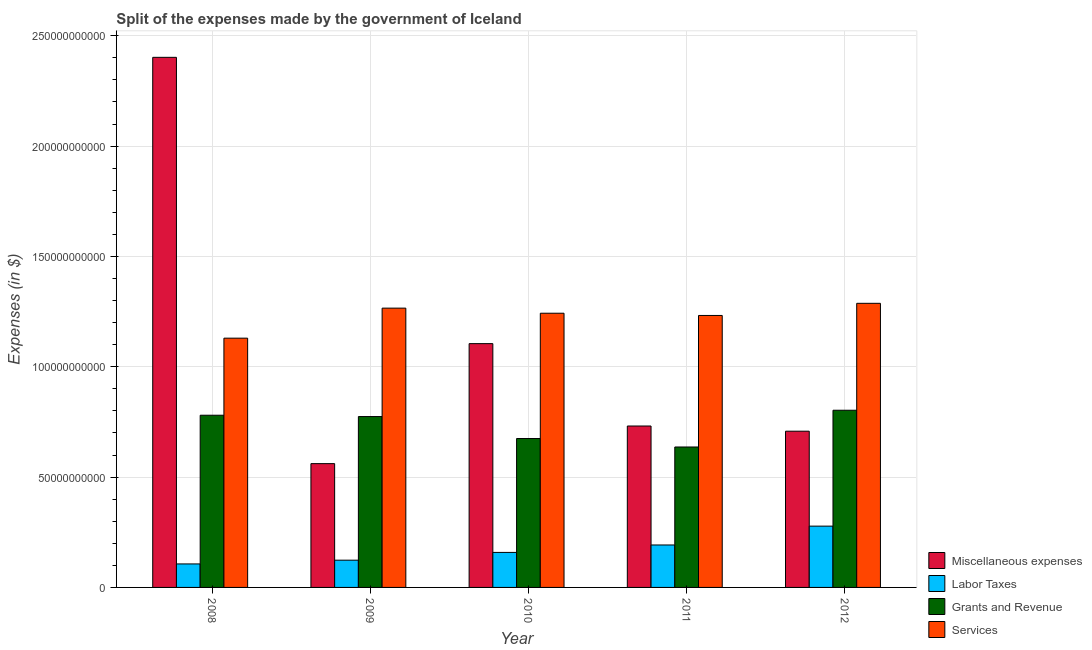How many groups of bars are there?
Give a very brief answer. 5. Are the number of bars on each tick of the X-axis equal?
Make the answer very short. Yes. How many bars are there on the 3rd tick from the left?
Provide a succinct answer. 4. What is the amount spent on services in 2012?
Make the answer very short. 1.29e+11. Across all years, what is the maximum amount spent on services?
Your response must be concise. 1.29e+11. Across all years, what is the minimum amount spent on miscellaneous expenses?
Provide a succinct answer. 5.61e+1. In which year was the amount spent on labor taxes minimum?
Your answer should be compact. 2008. What is the total amount spent on grants and revenue in the graph?
Keep it short and to the point. 3.67e+11. What is the difference between the amount spent on grants and revenue in 2008 and that in 2009?
Ensure brevity in your answer.  6.04e+08. What is the difference between the amount spent on miscellaneous expenses in 2009 and the amount spent on services in 2010?
Ensure brevity in your answer.  -5.44e+1. What is the average amount spent on services per year?
Offer a very short reply. 1.23e+11. In how many years, is the amount spent on grants and revenue greater than 70000000000 $?
Ensure brevity in your answer.  3. What is the ratio of the amount spent on miscellaneous expenses in 2008 to that in 2011?
Give a very brief answer. 3.28. Is the difference between the amount spent on services in 2008 and 2009 greater than the difference between the amount spent on grants and revenue in 2008 and 2009?
Ensure brevity in your answer.  No. What is the difference between the highest and the second highest amount spent on grants and revenue?
Provide a succinct answer. 2.26e+09. What is the difference between the highest and the lowest amount spent on labor taxes?
Your answer should be very brief. 1.71e+1. Is the sum of the amount spent on miscellaneous expenses in 2010 and 2012 greater than the maximum amount spent on grants and revenue across all years?
Offer a very short reply. No. Is it the case that in every year, the sum of the amount spent on services and amount spent on labor taxes is greater than the sum of amount spent on miscellaneous expenses and amount spent on grants and revenue?
Give a very brief answer. No. What does the 3rd bar from the left in 2012 represents?
Keep it short and to the point. Grants and Revenue. What does the 1st bar from the right in 2010 represents?
Offer a terse response. Services. Is it the case that in every year, the sum of the amount spent on miscellaneous expenses and amount spent on labor taxes is greater than the amount spent on grants and revenue?
Your response must be concise. No. How many bars are there?
Your response must be concise. 20. Are all the bars in the graph horizontal?
Provide a short and direct response. No. How many years are there in the graph?
Keep it short and to the point. 5. Are the values on the major ticks of Y-axis written in scientific E-notation?
Keep it short and to the point. No. Where does the legend appear in the graph?
Keep it short and to the point. Bottom right. What is the title of the graph?
Give a very brief answer. Split of the expenses made by the government of Iceland. Does "Gender equality" appear as one of the legend labels in the graph?
Keep it short and to the point. No. What is the label or title of the Y-axis?
Your response must be concise. Expenses (in $). What is the Expenses (in $) in Miscellaneous expenses in 2008?
Your answer should be very brief. 2.40e+11. What is the Expenses (in $) of Labor Taxes in 2008?
Offer a very short reply. 1.06e+1. What is the Expenses (in $) in Grants and Revenue in 2008?
Your answer should be compact. 7.80e+1. What is the Expenses (in $) in Services in 2008?
Make the answer very short. 1.13e+11. What is the Expenses (in $) of Miscellaneous expenses in 2009?
Provide a short and direct response. 5.61e+1. What is the Expenses (in $) of Labor Taxes in 2009?
Provide a succinct answer. 1.23e+1. What is the Expenses (in $) of Grants and Revenue in 2009?
Make the answer very short. 7.74e+1. What is the Expenses (in $) of Services in 2009?
Ensure brevity in your answer.  1.27e+11. What is the Expenses (in $) of Miscellaneous expenses in 2010?
Your answer should be compact. 1.10e+11. What is the Expenses (in $) in Labor Taxes in 2010?
Ensure brevity in your answer.  1.59e+1. What is the Expenses (in $) of Grants and Revenue in 2010?
Make the answer very short. 6.75e+1. What is the Expenses (in $) in Services in 2010?
Your answer should be very brief. 1.24e+11. What is the Expenses (in $) of Miscellaneous expenses in 2011?
Keep it short and to the point. 7.31e+1. What is the Expenses (in $) of Labor Taxes in 2011?
Provide a short and direct response. 1.92e+1. What is the Expenses (in $) in Grants and Revenue in 2011?
Make the answer very short. 6.36e+1. What is the Expenses (in $) of Services in 2011?
Your response must be concise. 1.23e+11. What is the Expenses (in $) of Miscellaneous expenses in 2012?
Your answer should be compact. 7.08e+1. What is the Expenses (in $) of Labor Taxes in 2012?
Your answer should be compact. 2.78e+1. What is the Expenses (in $) in Grants and Revenue in 2012?
Give a very brief answer. 8.03e+1. What is the Expenses (in $) of Services in 2012?
Your answer should be very brief. 1.29e+11. Across all years, what is the maximum Expenses (in $) of Miscellaneous expenses?
Provide a succinct answer. 2.40e+11. Across all years, what is the maximum Expenses (in $) in Labor Taxes?
Your answer should be very brief. 2.78e+1. Across all years, what is the maximum Expenses (in $) in Grants and Revenue?
Keep it short and to the point. 8.03e+1. Across all years, what is the maximum Expenses (in $) in Services?
Your answer should be compact. 1.29e+11. Across all years, what is the minimum Expenses (in $) of Miscellaneous expenses?
Provide a succinct answer. 5.61e+1. Across all years, what is the minimum Expenses (in $) of Labor Taxes?
Your answer should be very brief. 1.06e+1. Across all years, what is the minimum Expenses (in $) of Grants and Revenue?
Ensure brevity in your answer.  6.36e+1. Across all years, what is the minimum Expenses (in $) of Services?
Make the answer very short. 1.13e+11. What is the total Expenses (in $) in Miscellaneous expenses in the graph?
Offer a terse response. 5.51e+11. What is the total Expenses (in $) in Labor Taxes in the graph?
Offer a terse response. 8.59e+1. What is the total Expenses (in $) of Grants and Revenue in the graph?
Make the answer very short. 3.67e+11. What is the total Expenses (in $) of Services in the graph?
Offer a very short reply. 6.16e+11. What is the difference between the Expenses (in $) of Miscellaneous expenses in 2008 and that in 2009?
Provide a short and direct response. 1.84e+11. What is the difference between the Expenses (in $) of Labor Taxes in 2008 and that in 2009?
Make the answer very short. -1.70e+09. What is the difference between the Expenses (in $) of Grants and Revenue in 2008 and that in 2009?
Ensure brevity in your answer.  6.04e+08. What is the difference between the Expenses (in $) in Services in 2008 and that in 2009?
Keep it short and to the point. -1.36e+1. What is the difference between the Expenses (in $) of Miscellaneous expenses in 2008 and that in 2010?
Your answer should be compact. 1.30e+11. What is the difference between the Expenses (in $) of Labor Taxes in 2008 and that in 2010?
Keep it short and to the point. -5.21e+09. What is the difference between the Expenses (in $) in Grants and Revenue in 2008 and that in 2010?
Your answer should be compact. 1.06e+1. What is the difference between the Expenses (in $) of Services in 2008 and that in 2010?
Make the answer very short. -1.13e+1. What is the difference between the Expenses (in $) of Miscellaneous expenses in 2008 and that in 2011?
Your response must be concise. 1.67e+11. What is the difference between the Expenses (in $) in Labor Taxes in 2008 and that in 2011?
Your answer should be very brief. -8.59e+09. What is the difference between the Expenses (in $) of Grants and Revenue in 2008 and that in 2011?
Provide a short and direct response. 1.44e+1. What is the difference between the Expenses (in $) of Services in 2008 and that in 2011?
Keep it short and to the point. -1.03e+1. What is the difference between the Expenses (in $) of Miscellaneous expenses in 2008 and that in 2012?
Provide a short and direct response. 1.69e+11. What is the difference between the Expenses (in $) of Labor Taxes in 2008 and that in 2012?
Your answer should be compact. -1.71e+1. What is the difference between the Expenses (in $) of Grants and Revenue in 2008 and that in 2012?
Give a very brief answer. -2.26e+09. What is the difference between the Expenses (in $) of Services in 2008 and that in 2012?
Your response must be concise. -1.58e+1. What is the difference between the Expenses (in $) in Miscellaneous expenses in 2009 and that in 2010?
Ensure brevity in your answer.  -5.44e+1. What is the difference between the Expenses (in $) in Labor Taxes in 2009 and that in 2010?
Keep it short and to the point. -3.52e+09. What is the difference between the Expenses (in $) of Grants and Revenue in 2009 and that in 2010?
Give a very brief answer. 9.95e+09. What is the difference between the Expenses (in $) in Services in 2009 and that in 2010?
Your answer should be compact. 2.31e+09. What is the difference between the Expenses (in $) in Miscellaneous expenses in 2009 and that in 2011?
Offer a very short reply. -1.70e+1. What is the difference between the Expenses (in $) in Labor Taxes in 2009 and that in 2011?
Provide a succinct answer. -6.89e+09. What is the difference between the Expenses (in $) of Grants and Revenue in 2009 and that in 2011?
Your response must be concise. 1.38e+1. What is the difference between the Expenses (in $) in Services in 2009 and that in 2011?
Ensure brevity in your answer.  3.32e+09. What is the difference between the Expenses (in $) in Miscellaneous expenses in 2009 and that in 2012?
Make the answer very short. -1.47e+1. What is the difference between the Expenses (in $) of Labor Taxes in 2009 and that in 2012?
Give a very brief answer. -1.54e+1. What is the difference between the Expenses (in $) in Grants and Revenue in 2009 and that in 2012?
Keep it short and to the point. -2.86e+09. What is the difference between the Expenses (in $) of Services in 2009 and that in 2012?
Ensure brevity in your answer.  -2.18e+09. What is the difference between the Expenses (in $) in Miscellaneous expenses in 2010 and that in 2011?
Ensure brevity in your answer.  3.73e+1. What is the difference between the Expenses (in $) of Labor Taxes in 2010 and that in 2011?
Your answer should be very brief. -3.38e+09. What is the difference between the Expenses (in $) in Grants and Revenue in 2010 and that in 2011?
Your answer should be compact. 3.84e+09. What is the difference between the Expenses (in $) of Services in 2010 and that in 2011?
Your response must be concise. 1.01e+09. What is the difference between the Expenses (in $) of Miscellaneous expenses in 2010 and that in 2012?
Give a very brief answer. 3.97e+1. What is the difference between the Expenses (in $) of Labor Taxes in 2010 and that in 2012?
Offer a terse response. -1.19e+1. What is the difference between the Expenses (in $) in Grants and Revenue in 2010 and that in 2012?
Your answer should be compact. -1.28e+1. What is the difference between the Expenses (in $) of Services in 2010 and that in 2012?
Your answer should be compact. -4.49e+09. What is the difference between the Expenses (in $) of Miscellaneous expenses in 2011 and that in 2012?
Make the answer very short. 2.35e+09. What is the difference between the Expenses (in $) of Labor Taxes in 2011 and that in 2012?
Keep it short and to the point. -8.53e+09. What is the difference between the Expenses (in $) of Grants and Revenue in 2011 and that in 2012?
Your response must be concise. -1.67e+1. What is the difference between the Expenses (in $) in Services in 2011 and that in 2012?
Provide a short and direct response. -5.50e+09. What is the difference between the Expenses (in $) in Miscellaneous expenses in 2008 and the Expenses (in $) in Labor Taxes in 2009?
Give a very brief answer. 2.28e+11. What is the difference between the Expenses (in $) of Miscellaneous expenses in 2008 and the Expenses (in $) of Grants and Revenue in 2009?
Offer a terse response. 1.63e+11. What is the difference between the Expenses (in $) of Miscellaneous expenses in 2008 and the Expenses (in $) of Services in 2009?
Give a very brief answer. 1.14e+11. What is the difference between the Expenses (in $) in Labor Taxes in 2008 and the Expenses (in $) in Grants and Revenue in 2009?
Your response must be concise. -6.68e+1. What is the difference between the Expenses (in $) of Labor Taxes in 2008 and the Expenses (in $) of Services in 2009?
Give a very brief answer. -1.16e+11. What is the difference between the Expenses (in $) of Grants and Revenue in 2008 and the Expenses (in $) of Services in 2009?
Give a very brief answer. -4.85e+1. What is the difference between the Expenses (in $) in Miscellaneous expenses in 2008 and the Expenses (in $) in Labor Taxes in 2010?
Your response must be concise. 2.24e+11. What is the difference between the Expenses (in $) in Miscellaneous expenses in 2008 and the Expenses (in $) in Grants and Revenue in 2010?
Make the answer very short. 1.73e+11. What is the difference between the Expenses (in $) of Miscellaneous expenses in 2008 and the Expenses (in $) of Services in 2010?
Offer a very short reply. 1.16e+11. What is the difference between the Expenses (in $) of Labor Taxes in 2008 and the Expenses (in $) of Grants and Revenue in 2010?
Provide a short and direct response. -5.68e+1. What is the difference between the Expenses (in $) of Labor Taxes in 2008 and the Expenses (in $) of Services in 2010?
Offer a very short reply. -1.14e+11. What is the difference between the Expenses (in $) in Grants and Revenue in 2008 and the Expenses (in $) in Services in 2010?
Ensure brevity in your answer.  -4.62e+1. What is the difference between the Expenses (in $) in Miscellaneous expenses in 2008 and the Expenses (in $) in Labor Taxes in 2011?
Offer a terse response. 2.21e+11. What is the difference between the Expenses (in $) of Miscellaneous expenses in 2008 and the Expenses (in $) of Grants and Revenue in 2011?
Offer a very short reply. 1.77e+11. What is the difference between the Expenses (in $) of Miscellaneous expenses in 2008 and the Expenses (in $) of Services in 2011?
Your answer should be very brief. 1.17e+11. What is the difference between the Expenses (in $) in Labor Taxes in 2008 and the Expenses (in $) in Grants and Revenue in 2011?
Your answer should be compact. -5.30e+1. What is the difference between the Expenses (in $) of Labor Taxes in 2008 and the Expenses (in $) of Services in 2011?
Give a very brief answer. -1.13e+11. What is the difference between the Expenses (in $) in Grants and Revenue in 2008 and the Expenses (in $) in Services in 2011?
Make the answer very short. -4.52e+1. What is the difference between the Expenses (in $) in Miscellaneous expenses in 2008 and the Expenses (in $) in Labor Taxes in 2012?
Make the answer very short. 2.12e+11. What is the difference between the Expenses (in $) in Miscellaneous expenses in 2008 and the Expenses (in $) in Grants and Revenue in 2012?
Provide a short and direct response. 1.60e+11. What is the difference between the Expenses (in $) of Miscellaneous expenses in 2008 and the Expenses (in $) of Services in 2012?
Provide a short and direct response. 1.11e+11. What is the difference between the Expenses (in $) of Labor Taxes in 2008 and the Expenses (in $) of Grants and Revenue in 2012?
Keep it short and to the point. -6.96e+1. What is the difference between the Expenses (in $) in Labor Taxes in 2008 and the Expenses (in $) in Services in 2012?
Your answer should be very brief. -1.18e+11. What is the difference between the Expenses (in $) in Grants and Revenue in 2008 and the Expenses (in $) in Services in 2012?
Your answer should be very brief. -5.07e+1. What is the difference between the Expenses (in $) of Miscellaneous expenses in 2009 and the Expenses (in $) of Labor Taxes in 2010?
Offer a very short reply. 4.02e+1. What is the difference between the Expenses (in $) of Miscellaneous expenses in 2009 and the Expenses (in $) of Grants and Revenue in 2010?
Your answer should be compact. -1.14e+1. What is the difference between the Expenses (in $) in Miscellaneous expenses in 2009 and the Expenses (in $) in Services in 2010?
Your response must be concise. -6.82e+1. What is the difference between the Expenses (in $) of Labor Taxes in 2009 and the Expenses (in $) of Grants and Revenue in 2010?
Keep it short and to the point. -5.51e+1. What is the difference between the Expenses (in $) in Labor Taxes in 2009 and the Expenses (in $) in Services in 2010?
Your answer should be very brief. -1.12e+11. What is the difference between the Expenses (in $) in Grants and Revenue in 2009 and the Expenses (in $) in Services in 2010?
Provide a succinct answer. -4.68e+1. What is the difference between the Expenses (in $) in Miscellaneous expenses in 2009 and the Expenses (in $) in Labor Taxes in 2011?
Keep it short and to the point. 3.69e+1. What is the difference between the Expenses (in $) in Miscellaneous expenses in 2009 and the Expenses (in $) in Grants and Revenue in 2011?
Give a very brief answer. -7.54e+09. What is the difference between the Expenses (in $) of Miscellaneous expenses in 2009 and the Expenses (in $) of Services in 2011?
Offer a terse response. -6.71e+1. What is the difference between the Expenses (in $) in Labor Taxes in 2009 and the Expenses (in $) in Grants and Revenue in 2011?
Your answer should be compact. -5.13e+1. What is the difference between the Expenses (in $) in Labor Taxes in 2009 and the Expenses (in $) in Services in 2011?
Your answer should be very brief. -1.11e+11. What is the difference between the Expenses (in $) of Grants and Revenue in 2009 and the Expenses (in $) of Services in 2011?
Ensure brevity in your answer.  -4.58e+1. What is the difference between the Expenses (in $) of Miscellaneous expenses in 2009 and the Expenses (in $) of Labor Taxes in 2012?
Provide a succinct answer. 2.83e+1. What is the difference between the Expenses (in $) of Miscellaneous expenses in 2009 and the Expenses (in $) of Grants and Revenue in 2012?
Offer a very short reply. -2.42e+1. What is the difference between the Expenses (in $) in Miscellaneous expenses in 2009 and the Expenses (in $) in Services in 2012?
Provide a succinct answer. -7.26e+1. What is the difference between the Expenses (in $) of Labor Taxes in 2009 and the Expenses (in $) of Grants and Revenue in 2012?
Make the answer very short. -6.79e+1. What is the difference between the Expenses (in $) of Labor Taxes in 2009 and the Expenses (in $) of Services in 2012?
Your answer should be compact. -1.16e+11. What is the difference between the Expenses (in $) in Grants and Revenue in 2009 and the Expenses (in $) in Services in 2012?
Provide a short and direct response. -5.13e+1. What is the difference between the Expenses (in $) of Miscellaneous expenses in 2010 and the Expenses (in $) of Labor Taxes in 2011?
Give a very brief answer. 9.12e+1. What is the difference between the Expenses (in $) in Miscellaneous expenses in 2010 and the Expenses (in $) in Grants and Revenue in 2011?
Give a very brief answer. 4.68e+1. What is the difference between the Expenses (in $) in Miscellaneous expenses in 2010 and the Expenses (in $) in Services in 2011?
Make the answer very short. -1.28e+1. What is the difference between the Expenses (in $) of Labor Taxes in 2010 and the Expenses (in $) of Grants and Revenue in 2011?
Give a very brief answer. -4.78e+1. What is the difference between the Expenses (in $) of Labor Taxes in 2010 and the Expenses (in $) of Services in 2011?
Offer a very short reply. -1.07e+11. What is the difference between the Expenses (in $) of Grants and Revenue in 2010 and the Expenses (in $) of Services in 2011?
Your response must be concise. -5.58e+1. What is the difference between the Expenses (in $) in Miscellaneous expenses in 2010 and the Expenses (in $) in Labor Taxes in 2012?
Your answer should be compact. 8.27e+1. What is the difference between the Expenses (in $) in Miscellaneous expenses in 2010 and the Expenses (in $) in Grants and Revenue in 2012?
Provide a succinct answer. 3.02e+1. What is the difference between the Expenses (in $) of Miscellaneous expenses in 2010 and the Expenses (in $) of Services in 2012?
Offer a terse response. -1.83e+1. What is the difference between the Expenses (in $) in Labor Taxes in 2010 and the Expenses (in $) in Grants and Revenue in 2012?
Provide a succinct answer. -6.44e+1. What is the difference between the Expenses (in $) of Labor Taxes in 2010 and the Expenses (in $) of Services in 2012?
Keep it short and to the point. -1.13e+11. What is the difference between the Expenses (in $) in Grants and Revenue in 2010 and the Expenses (in $) in Services in 2012?
Your answer should be compact. -6.13e+1. What is the difference between the Expenses (in $) in Miscellaneous expenses in 2011 and the Expenses (in $) in Labor Taxes in 2012?
Offer a terse response. 4.54e+1. What is the difference between the Expenses (in $) in Miscellaneous expenses in 2011 and the Expenses (in $) in Grants and Revenue in 2012?
Your response must be concise. -7.15e+09. What is the difference between the Expenses (in $) in Miscellaneous expenses in 2011 and the Expenses (in $) in Services in 2012?
Keep it short and to the point. -5.56e+1. What is the difference between the Expenses (in $) in Labor Taxes in 2011 and the Expenses (in $) in Grants and Revenue in 2012?
Keep it short and to the point. -6.11e+1. What is the difference between the Expenses (in $) of Labor Taxes in 2011 and the Expenses (in $) of Services in 2012?
Offer a very short reply. -1.10e+11. What is the difference between the Expenses (in $) of Grants and Revenue in 2011 and the Expenses (in $) of Services in 2012?
Keep it short and to the point. -6.51e+1. What is the average Expenses (in $) of Miscellaneous expenses per year?
Keep it short and to the point. 1.10e+11. What is the average Expenses (in $) in Labor Taxes per year?
Ensure brevity in your answer.  1.72e+1. What is the average Expenses (in $) in Grants and Revenue per year?
Make the answer very short. 7.34e+1. What is the average Expenses (in $) of Services per year?
Offer a very short reply. 1.23e+11. In the year 2008, what is the difference between the Expenses (in $) of Miscellaneous expenses and Expenses (in $) of Labor Taxes?
Offer a terse response. 2.30e+11. In the year 2008, what is the difference between the Expenses (in $) of Miscellaneous expenses and Expenses (in $) of Grants and Revenue?
Make the answer very short. 1.62e+11. In the year 2008, what is the difference between the Expenses (in $) of Miscellaneous expenses and Expenses (in $) of Services?
Your answer should be very brief. 1.27e+11. In the year 2008, what is the difference between the Expenses (in $) in Labor Taxes and Expenses (in $) in Grants and Revenue?
Keep it short and to the point. -6.74e+1. In the year 2008, what is the difference between the Expenses (in $) of Labor Taxes and Expenses (in $) of Services?
Your answer should be compact. -1.02e+11. In the year 2008, what is the difference between the Expenses (in $) of Grants and Revenue and Expenses (in $) of Services?
Your answer should be compact. -3.49e+1. In the year 2009, what is the difference between the Expenses (in $) in Miscellaneous expenses and Expenses (in $) in Labor Taxes?
Your response must be concise. 4.38e+1. In the year 2009, what is the difference between the Expenses (in $) in Miscellaneous expenses and Expenses (in $) in Grants and Revenue?
Your response must be concise. -2.13e+1. In the year 2009, what is the difference between the Expenses (in $) of Miscellaneous expenses and Expenses (in $) of Services?
Provide a short and direct response. -7.05e+1. In the year 2009, what is the difference between the Expenses (in $) in Labor Taxes and Expenses (in $) in Grants and Revenue?
Keep it short and to the point. -6.51e+1. In the year 2009, what is the difference between the Expenses (in $) of Labor Taxes and Expenses (in $) of Services?
Provide a succinct answer. -1.14e+11. In the year 2009, what is the difference between the Expenses (in $) in Grants and Revenue and Expenses (in $) in Services?
Your answer should be compact. -4.91e+1. In the year 2010, what is the difference between the Expenses (in $) of Miscellaneous expenses and Expenses (in $) of Labor Taxes?
Your answer should be compact. 9.46e+1. In the year 2010, what is the difference between the Expenses (in $) in Miscellaneous expenses and Expenses (in $) in Grants and Revenue?
Offer a terse response. 4.30e+1. In the year 2010, what is the difference between the Expenses (in $) in Miscellaneous expenses and Expenses (in $) in Services?
Offer a terse response. -1.38e+1. In the year 2010, what is the difference between the Expenses (in $) of Labor Taxes and Expenses (in $) of Grants and Revenue?
Provide a succinct answer. -5.16e+1. In the year 2010, what is the difference between the Expenses (in $) of Labor Taxes and Expenses (in $) of Services?
Offer a very short reply. -1.08e+11. In the year 2010, what is the difference between the Expenses (in $) in Grants and Revenue and Expenses (in $) in Services?
Provide a succinct answer. -5.68e+1. In the year 2011, what is the difference between the Expenses (in $) of Miscellaneous expenses and Expenses (in $) of Labor Taxes?
Give a very brief answer. 5.39e+1. In the year 2011, what is the difference between the Expenses (in $) in Miscellaneous expenses and Expenses (in $) in Grants and Revenue?
Your answer should be very brief. 9.51e+09. In the year 2011, what is the difference between the Expenses (in $) in Miscellaneous expenses and Expenses (in $) in Services?
Your answer should be compact. -5.01e+1. In the year 2011, what is the difference between the Expenses (in $) in Labor Taxes and Expenses (in $) in Grants and Revenue?
Offer a very short reply. -4.44e+1. In the year 2011, what is the difference between the Expenses (in $) of Labor Taxes and Expenses (in $) of Services?
Your response must be concise. -1.04e+11. In the year 2011, what is the difference between the Expenses (in $) of Grants and Revenue and Expenses (in $) of Services?
Provide a succinct answer. -5.96e+1. In the year 2012, what is the difference between the Expenses (in $) in Miscellaneous expenses and Expenses (in $) in Labor Taxes?
Give a very brief answer. 4.30e+1. In the year 2012, what is the difference between the Expenses (in $) in Miscellaneous expenses and Expenses (in $) in Grants and Revenue?
Your response must be concise. -9.50e+09. In the year 2012, what is the difference between the Expenses (in $) in Miscellaneous expenses and Expenses (in $) in Services?
Provide a short and direct response. -5.79e+1. In the year 2012, what is the difference between the Expenses (in $) of Labor Taxes and Expenses (in $) of Grants and Revenue?
Your response must be concise. -5.25e+1. In the year 2012, what is the difference between the Expenses (in $) of Labor Taxes and Expenses (in $) of Services?
Give a very brief answer. -1.01e+11. In the year 2012, what is the difference between the Expenses (in $) of Grants and Revenue and Expenses (in $) of Services?
Give a very brief answer. -4.84e+1. What is the ratio of the Expenses (in $) of Miscellaneous expenses in 2008 to that in 2009?
Ensure brevity in your answer.  4.28. What is the ratio of the Expenses (in $) in Labor Taxes in 2008 to that in 2009?
Ensure brevity in your answer.  0.86. What is the ratio of the Expenses (in $) in Grants and Revenue in 2008 to that in 2009?
Make the answer very short. 1.01. What is the ratio of the Expenses (in $) in Services in 2008 to that in 2009?
Your response must be concise. 0.89. What is the ratio of the Expenses (in $) in Miscellaneous expenses in 2008 to that in 2010?
Make the answer very short. 2.17. What is the ratio of the Expenses (in $) in Labor Taxes in 2008 to that in 2010?
Your response must be concise. 0.67. What is the ratio of the Expenses (in $) in Grants and Revenue in 2008 to that in 2010?
Make the answer very short. 1.16. What is the ratio of the Expenses (in $) of Services in 2008 to that in 2010?
Make the answer very short. 0.91. What is the ratio of the Expenses (in $) in Miscellaneous expenses in 2008 to that in 2011?
Give a very brief answer. 3.28. What is the ratio of the Expenses (in $) in Labor Taxes in 2008 to that in 2011?
Provide a short and direct response. 0.55. What is the ratio of the Expenses (in $) in Grants and Revenue in 2008 to that in 2011?
Your response must be concise. 1.23. What is the ratio of the Expenses (in $) in Services in 2008 to that in 2011?
Provide a succinct answer. 0.92. What is the ratio of the Expenses (in $) in Miscellaneous expenses in 2008 to that in 2012?
Ensure brevity in your answer.  3.39. What is the ratio of the Expenses (in $) of Labor Taxes in 2008 to that in 2012?
Your answer should be very brief. 0.38. What is the ratio of the Expenses (in $) in Grants and Revenue in 2008 to that in 2012?
Make the answer very short. 0.97. What is the ratio of the Expenses (in $) in Services in 2008 to that in 2012?
Provide a succinct answer. 0.88. What is the ratio of the Expenses (in $) of Miscellaneous expenses in 2009 to that in 2010?
Ensure brevity in your answer.  0.51. What is the ratio of the Expenses (in $) of Labor Taxes in 2009 to that in 2010?
Provide a succinct answer. 0.78. What is the ratio of the Expenses (in $) of Grants and Revenue in 2009 to that in 2010?
Ensure brevity in your answer.  1.15. What is the ratio of the Expenses (in $) in Services in 2009 to that in 2010?
Ensure brevity in your answer.  1.02. What is the ratio of the Expenses (in $) in Miscellaneous expenses in 2009 to that in 2011?
Your answer should be compact. 0.77. What is the ratio of the Expenses (in $) in Labor Taxes in 2009 to that in 2011?
Provide a succinct answer. 0.64. What is the ratio of the Expenses (in $) of Grants and Revenue in 2009 to that in 2011?
Offer a terse response. 1.22. What is the ratio of the Expenses (in $) of Services in 2009 to that in 2011?
Your answer should be very brief. 1.03. What is the ratio of the Expenses (in $) of Miscellaneous expenses in 2009 to that in 2012?
Give a very brief answer. 0.79. What is the ratio of the Expenses (in $) in Labor Taxes in 2009 to that in 2012?
Your answer should be compact. 0.44. What is the ratio of the Expenses (in $) of Grants and Revenue in 2009 to that in 2012?
Provide a succinct answer. 0.96. What is the ratio of the Expenses (in $) in Services in 2009 to that in 2012?
Provide a succinct answer. 0.98. What is the ratio of the Expenses (in $) of Miscellaneous expenses in 2010 to that in 2011?
Keep it short and to the point. 1.51. What is the ratio of the Expenses (in $) of Labor Taxes in 2010 to that in 2011?
Provide a succinct answer. 0.82. What is the ratio of the Expenses (in $) in Grants and Revenue in 2010 to that in 2011?
Your answer should be compact. 1.06. What is the ratio of the Expenses (in $) in Services in 2010 to that in 2011?
Your answer should be very brief. 1.01. What is the ratio of the Expenses (in $) in Miscellaneous expenses in 2010 to that in 2012?
Your answer should be very brief. 1.56. What is the ratio of the Expenses (in $) of Labor Taxes in 2010 to that in 2012?
Your response must be concise. 0.57. What is the ratio of the Expenses (in $) of Grants and Revenue in 2010 to that in 2012?
Keep it short and to the point. 0.84. What is the ratio of the Expenses (in $) in Services in 2010 to that in 2012?
Make the answer very short. 0.97. What is the ratio of the Expenses (in $) in Miscellaneous expenses in 2011 to that in 2012?
Your answer should be very brief. 1.03. What is the ratio of the Expenses (in $) of Labor Taxes in 2011 to that in 2012?
Provide a short and direct response. 0.69. What is the ratio of the Expenses (in $) in Grants and Revenue in 2011 to that in 2012?
Offer a very short reply. 0.79. What is the ratio of the Expenses (in $) in Services in 2011 to that in 2012?
Make the answer very short. 0.96. What is the difference between the highest and the second highest Expenses (in $) in Miscellaneous expenses?
Your answer should be very brief. 1.30e+11. What is the difference between the highest and the second highest Expenses (in $) of Labor Taxes?
Make the answer very short. 8.53e+09. What is the difference between the highest and the second highest Expenses (in $) in Grants and Revenue?
Your answer should be compact. 2.26e+09. What is the difference between the highest and the second highest Expenses (in $) of Services?
Ensure brevity in your answer.  2.18e+09. What is the difference between the highest and the lowest Expenses (in $) of Miscellaneous expenses?
Offer a very short reply. 1.84e+11. What is the difference between the highest and the lowest Expenses (in $) of Labor Taxes?
Your answer should be compact. 1.71e+1. What is the difference between the highest and the lowest Expenses (in $) in Grants and Revenue?
Make the answer very short. 1.67e+1. What is the difference between the highest and the lowest Expenses (in $) in Services?
Provide a succinct answer. 1.58e+1. 